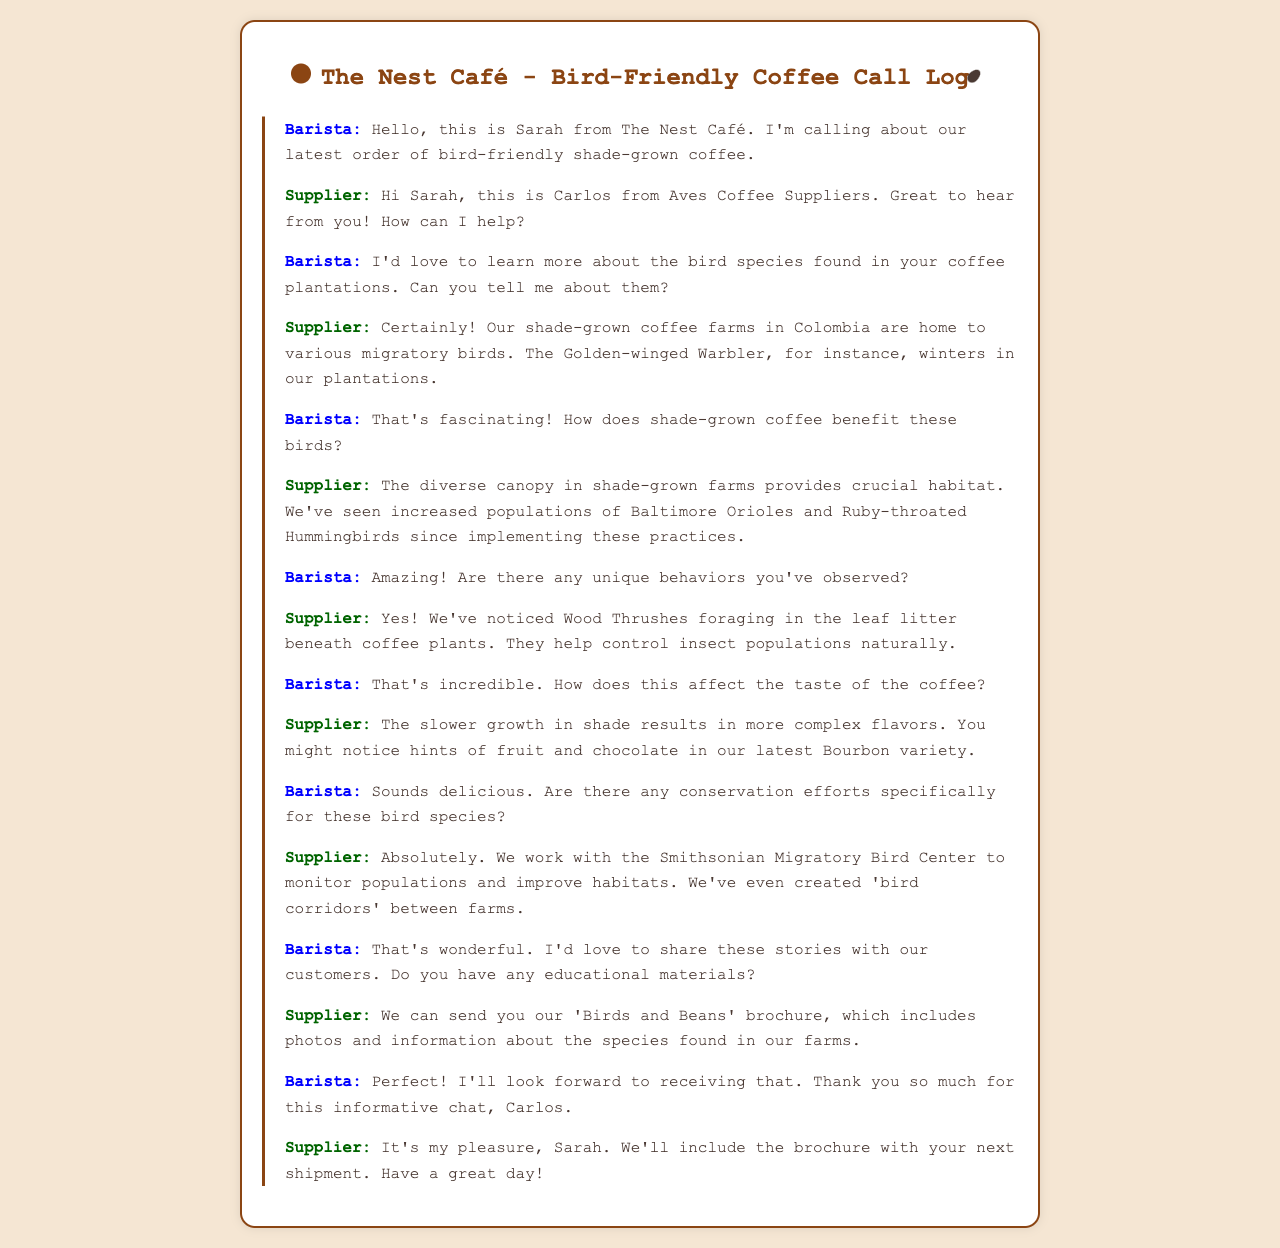What is the name of the barista? The barista introduces herself as Sarah.
Answer: Sarah Who is the supplier on the call? The supplier identifies himself as Carlos.
Answer: Carlos Which bird species winters in the plantations? The supplier mentions that the Golden-winged Warbler winters in their plantations.
Answer: Golden-winged Warbler What beneficial behavior do Wood Thrushes have? The Wood Thrushes forage in the leaf litter beneath coffee plants, helping control insect populations.
Answer: Control insect populations What organization does the supplier work with for conservation efforts? The supplier states they work with the Smithsonian Migratory Bird Center.
Answer: Smithsonian Migratory Bird Center What type of coffee variety is mentioned? The supplier talks about their latest Bourbon variety.
Answer: Bourbon What educational material is offered to the barista? The supplier can send the 'Birds and Beans' brochure.
Answer: 'Birds and Beans' brochure How does shade-grown coffee affect coffee flavor? The supplier explains that slower growth results in more complex flavors, including hints of fruit and chocolate.
Answer: More complex flavors What bird species has increased in population due to shade-grown practices? The supplier notes that they've seen increased populations of Baltimore Orioles.
Answer: Baltimore Orioles 